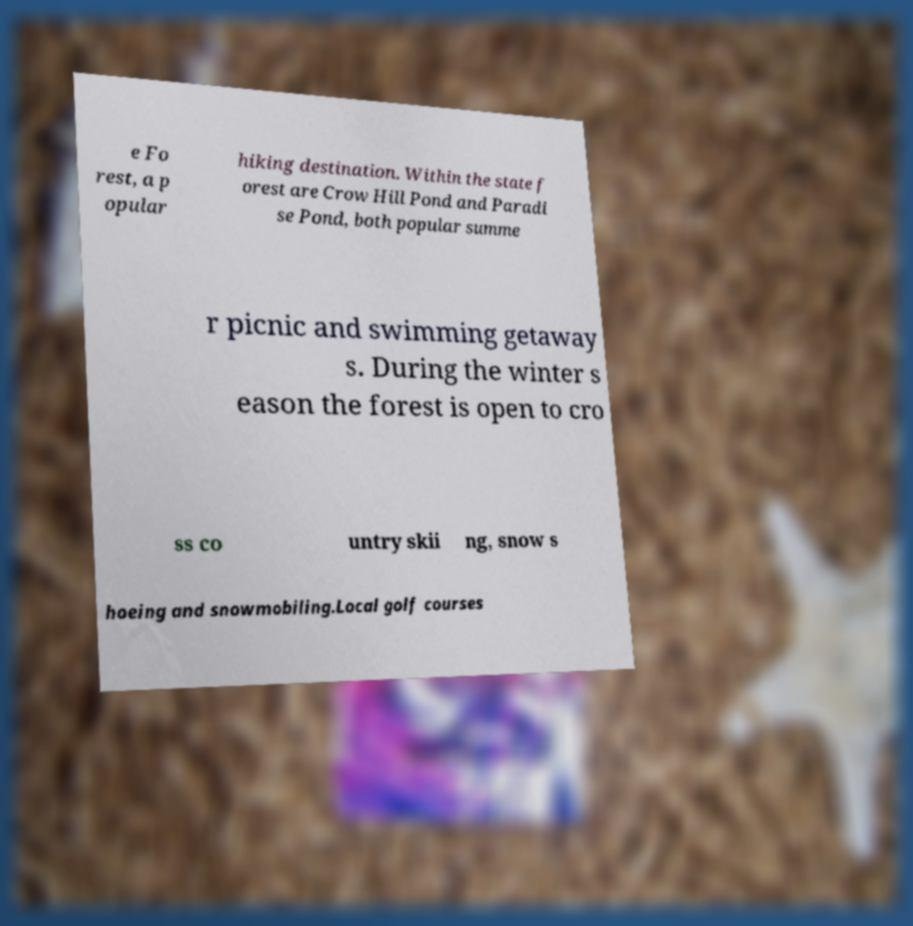Please read and relay the text visible in this image. What does it say? e Fo rest, a p opular hiking destination. Within the state f orest are Crow Hill Pond and Paradi se Pond, both popular summe r picnic and swimming getaway s. During the winter s eason the forest is open to cro ss co untry skii ng, snow s hoeing and snowmobiling.Local golf courses 